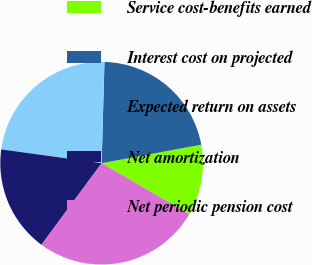<chart> <loc_0><loc_0><loc_500><loc_500><pie_chart><fcel>Service cost-benefits earned<fcel>Interest cost on projected<fcel>Expected return on assets<fcel>Net amortization<fcel>Net periodic pension cost<nl><fcel>11.3%<fcel>21.63%<fcel>23.26%<fcel>17.06%<fcel>26.74%<nl></chart> 